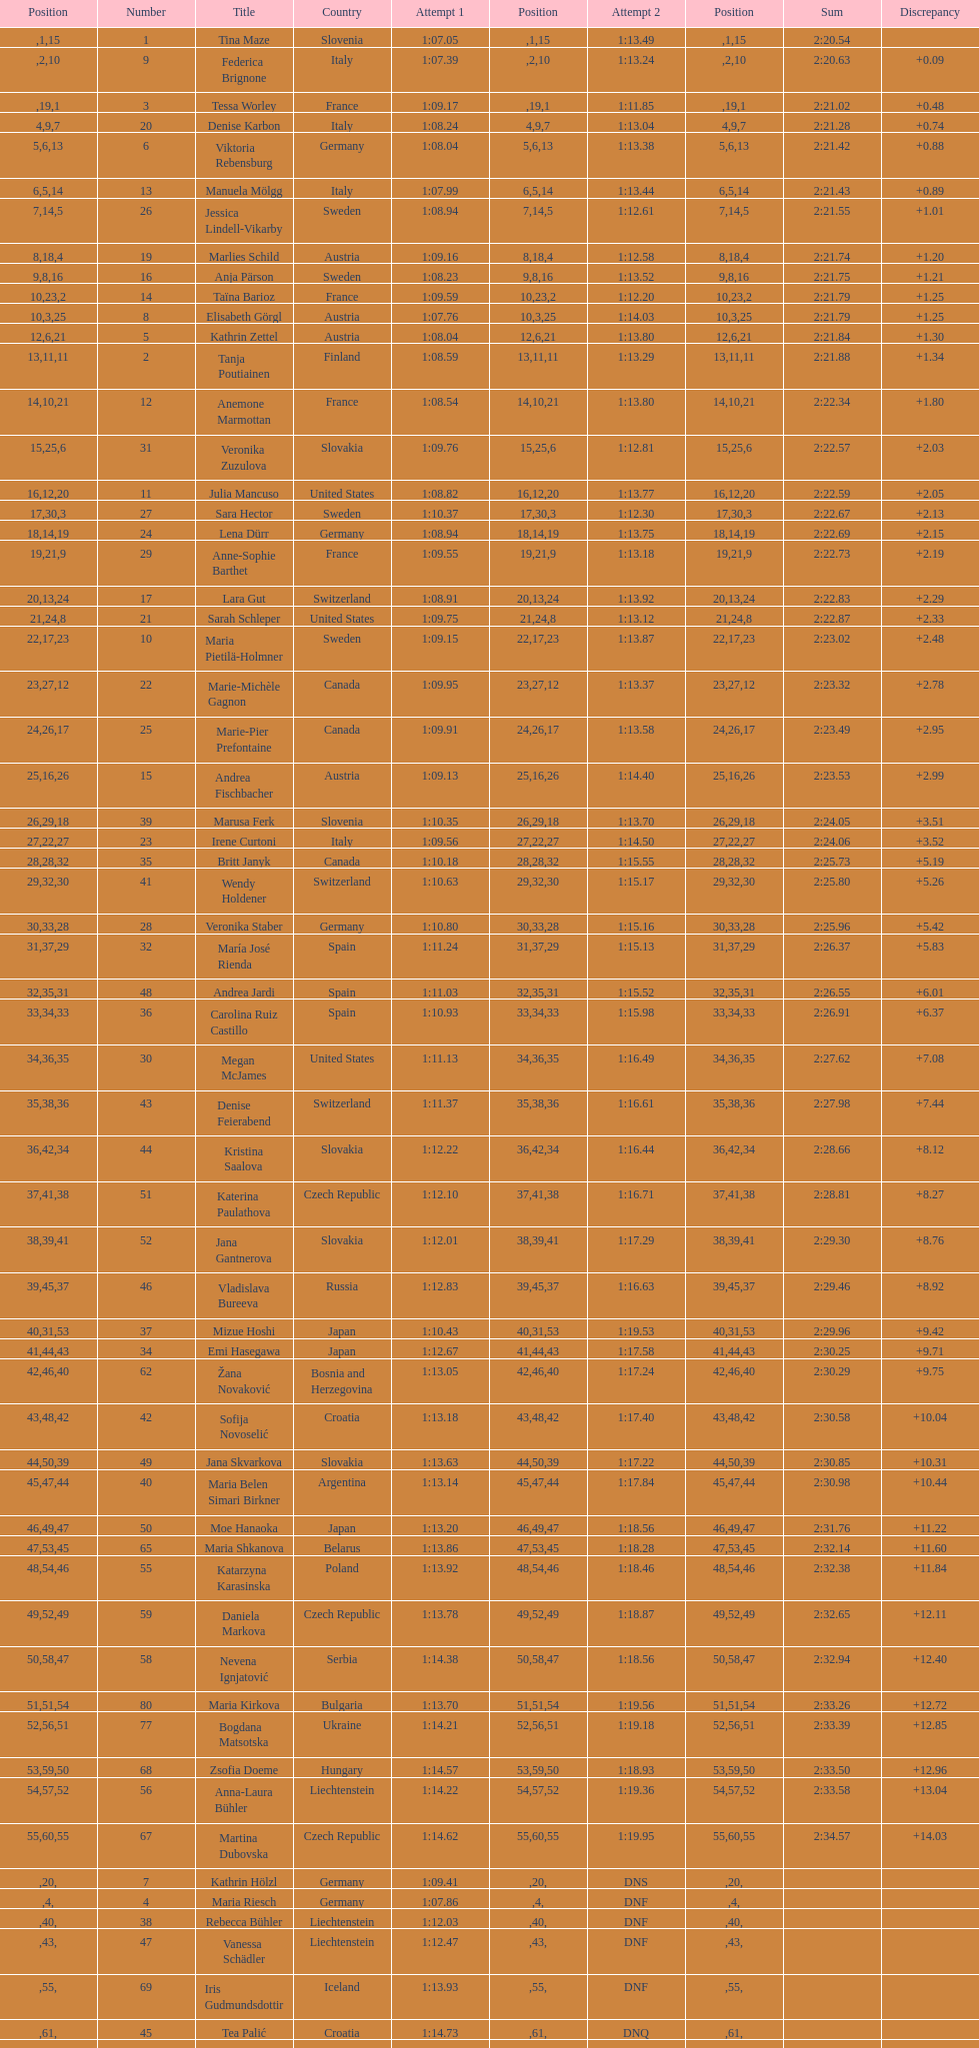What is the name before anja parson? Marlies Schild. 